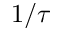Convert formula to latex. <formula><loc_0><loc_0><loc_500><loc_500>1 / \tau</formula> 